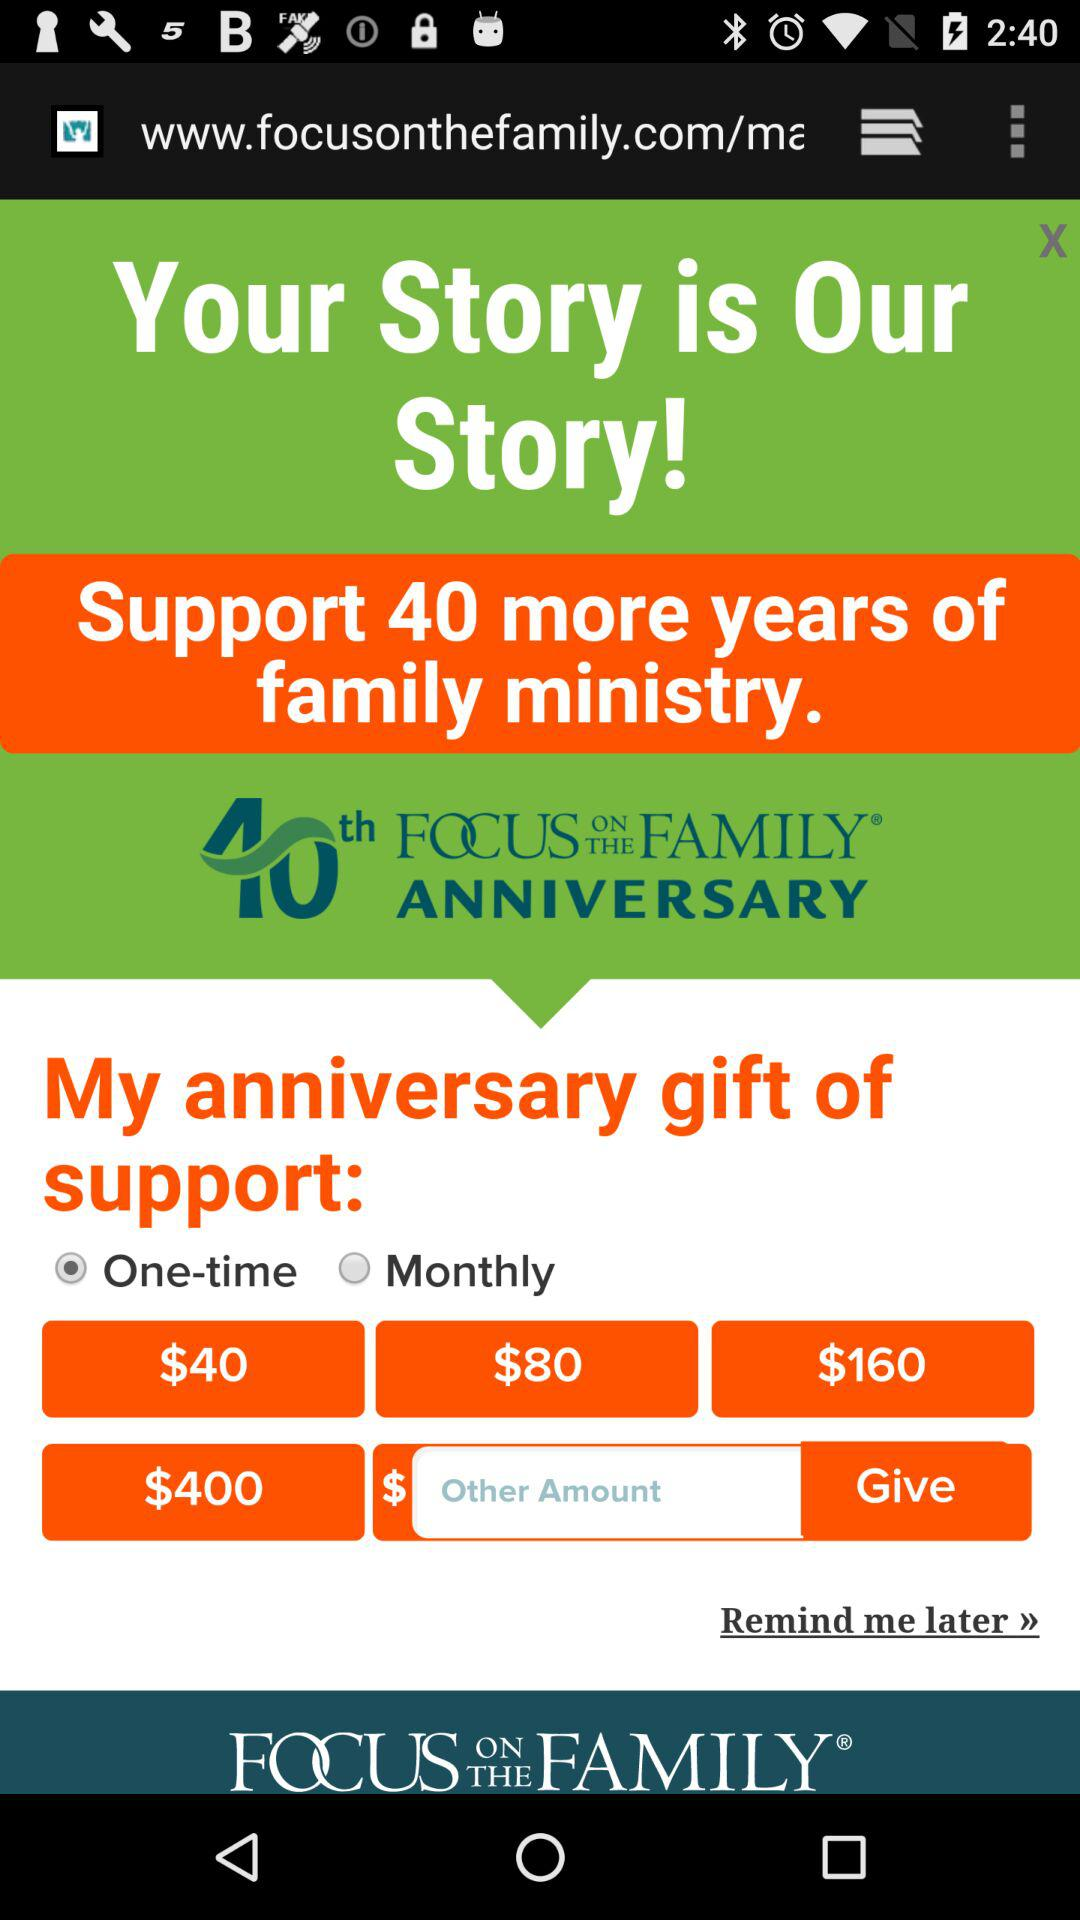Who is this application powered by?
When the provided information is insufficient, respond with <no answer>. <no answer> 